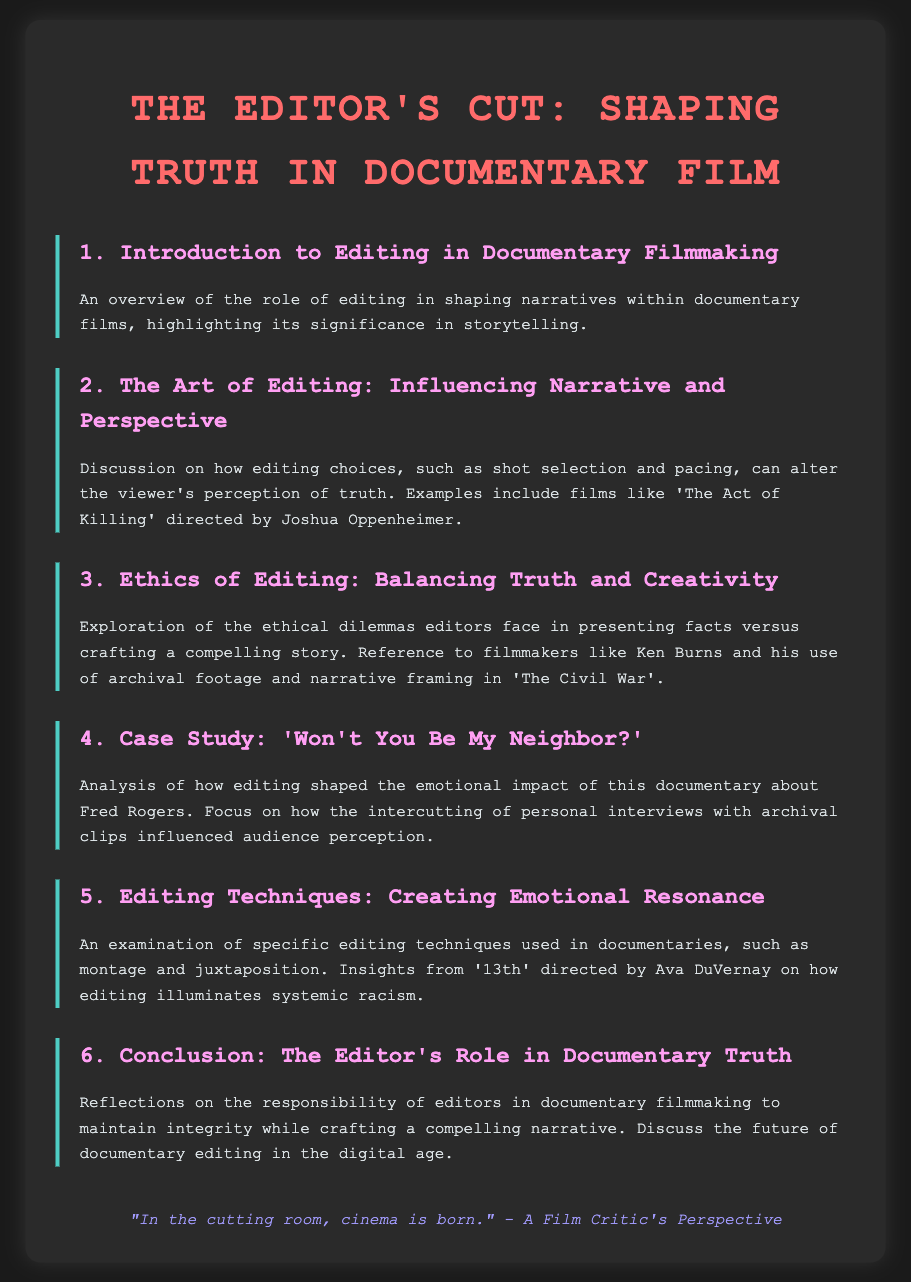What is the title of the document? The title is presented at the top of the agenda, highlighting the focus of the exploration.
Answer: The Editor's Cut: Shaping Truth in Documentary Film Who directed 'The Act of Killing'? The document specifies the director of this film as part of the discussion on editing choices and their impact.
Answer: Joshua Oppenheimer Which filmmaker is referenced for using archival footage in his documentary? This reference is included in the discussion about ethics in editing documentary films.
Answer: Ken Burns What is the focus of the case study in the agenda? The agenda item clearly states the subject of the case study, showcasing the emotional impact through editing.
Answer: 'Won't You Be My Neighbor?' What specific technique is examined in the context of documentaries? The document highlights various editing techniques that contribute to storytelling within documentary filmmaking.
Answer: Montage and juxtaposition What is the overarching theme discussed in the conclusion? The conclusion reflects on the responsibility of editors, tying together the main theme of the agenda.
Answer: The Editor's Role in Documentary Truth Which documentary is mentioned in relation to systemic racism? The specific film is noted in terms of how editing illuminates the discussed theme.
Answer: '13th' What color is the text in the document? The color scheme is mentioned in the style definitions for the document, focusing on readability and aesthetic appeal.
Answer: #f0f0f0 